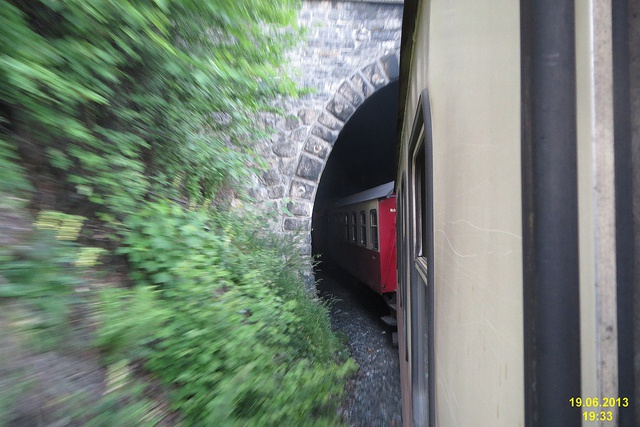Describe the objects in this image and their specific colors. I can see a train in darkgreen, gray, lightgray, darkgray, and black tones in this image. 